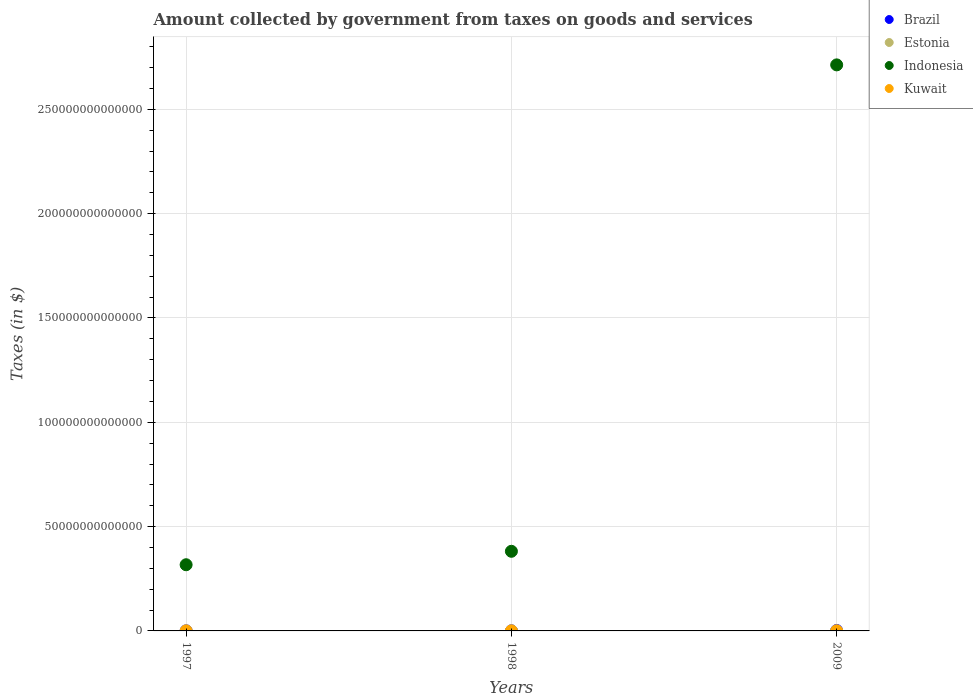Is the number of dotlines equal to the number of legend labels?
Provide a succinct answer. Yes. What is the amount collected by government from taxes on goods and services in Kuwait in 1998?
Make the answer very short. 1.00e+06. Across all years, what is the maximum amount collected by government from taxes on goods and services in Estonia?
Your response must be concise. 1.97e+09. In which year was the amount collected by government from taxes on goods and services in Estonia maximum?
Provide a short and direct response. 2009. In which year was the amount collected by government from taxes on goods and services in Brazil minimum?
Offer a very short reply. 1997. What is the total amount collected by government from taxes on goods and services in Kuwait in the graph?
Your response must be concise. 9.60e+07. What is the difference between the amount collected by government from taxes on goods and services in Kuwait in 1997 and that in 1998?
Offer a terse response. 0. What is the difference between the amount collected by government from taxes on goods and services in Kuwait in 1997 and the amount collected by government from taxes on goods and services in Indonesia in 2009?
Make the answer very short. -2.71e+14. What is the average amount collected by government from taxes on goods and services in Estonia per year?
Your answer should be very brief. 1.06e+09. In the year 1997, what is the difference between the amount collected by government from taxes on goods and services in Estonia and amount collected by government from taxes on goods and services in Indonesia?
Provide a short and direct response. -3.17e+13. In how many years, is the amount collected by government from taxes on goods and services in Estonia greater than 90000000000000 $?
Your answer should be compact. 0. What is the ratio of the amount collected by government from taxes on goods and services in Brazil in 1997 to that in 1998?
Make the answer very short. 0.91. Is the difference between the amount collected by government from taxes on goods and services in Estonia in 1997 and 2009 greater than the difference between the amount collected by government from taxes on goods and services in Indonesia in 1997 and 2009?
Provide a succinct answer. Yes. What is the difference between the highest and the second highest amount collected by government from taxes on goods and services in Estonia?
Give a very brief answer. 1.36e+09. What is the difference between the highest and the lowest amount collected by government from taxes on goods and services in Estonia?
Keep it short and to the point. 1.38e+09. Is the sum of the amount collected by government from taxes on goods and services in Estonia in 1998 and 2009 greater than the maximum amount collected by government from taxes on goods and services in Brazil across all years?
Your answer should be compact. No. Is it the case that in every year, the sum of the amount collected by government from taxes on goods and services in Indonesia and amount collected by government from taxes on goods and services in Kuwait  is greater than the sum of amount collected by government from taxes on goods and services in Estonia and amount collected by government from taxes on goods and services in Brazil?
Your response must be concise. No. Does the amount collected by government from taxes on goods and services in Indonesia monotonically increase over the years?
Give a very brief answer. Yes. Is the amount collected by government from taxes on goods and services in Brazil strictly greater than the amount collected by government from taxes on goods and services in Estonia over the years?
Make the answer very short. Yes. Is the amount collected by government from taxes on goods and services in Indonesia strictly less than the amount collected by government from taxes on goods and services in Estonia over the years?
Your response must be concise. No. How many years are there in the graph?
Provide a short and direct response. 3. What is the difference between two consecutive major ticks on the Y-axis?
Your response must be concise. 5.00e+13. Does the graph contain any zero values?
Provide a short and direct response. No. Does the graph contain grids?
Keep it short and to the point. Yes. How are the legend labels stacked?
Make the answer very short. Vertical. What is the title of the graph?
Your answer should be very brief. Amount collected by government from taxes on goods and services. Does "Serbia" appear as one of the legend labels in the graph?
Ensure brevity in your answer.  No. What is the label or title of the Y-axis?
Keep it short and to the point. Taxes (in $). What is the Taxes (in $) of Brazil in 1997?
Your response must be concise. 4.69e+1. What is the Taxes (in $) of Estonia in 1997?
Provide a succinct answer. 5.93e+08. What is the Taxes (in $) of Indonesia in 1997?
Ensure brevity in your answer.  3.17e+13. What is the Taxes (in $) of Brazil in 1998?
Keep it short and to the point. 5.17e+1. What is the Taxes (in $) in Estonia in 1998?
Make the answer very short. 6.05e+08. What is the Taxes (in $) in Indonesia in 1998?
Make the answer very short. 3.82e+13. What is the Taxes (in $) in Brazil in 2009?
Make the answer very short. 2.06e+11. What is the Taxes (in $) in Estonia in 2009?
Provide a succinct answer. 1.97e+09. What is the Taxes (in $) of Indonesia in 2009?
Offer a very short reply. 2.71e+14. What is the Taxes (in $) of Kuwait in 2009?
Offer a very short reply. 9.40e+07. Across all years, what is the maximum Taxes (in $) of Brazil?
Offer a very short reply. 2.06e+11. Across all years, what is the maximum Taxes (in $) in Estonia?
Make the answer very short. 1.97e+09. Across all years, what is the maximum Taxes (in $) of Indonesia?
Offer a very short reply. 2.71e+14. Across all years, what is the maximum Taxes (in $) in Kuwait?
Keep it short and to the point. 9.40e+07. Across all years, what is the minimum Taxes (in $) of Brazil?
Keep it short and to the point. 4.69e+1. Across all years, what is the minimum Taxes (in $) of Estonia?
Offer a very short reply. 5.93e+08. Across all years, what is the minimum Taxes (in $) of Indonesia?
Make the answer very short. 3.17e+13. What is the total Taxes (in $) of Brazil in the graph?
Provide a succinct answer. 3.04e+11. What is the total Taxes (in $) in Estonia in the graph?
Your response must be concise. 3.17e+09. What is the total Taxes (in $) in Indonesia in the graph?
Ensure brevity in your answer.  3.41e+14. What is the total Taxes (in $) in Kuwait in the graph?
Your answer should be very brief. 9.60e+07. What is the difference between the Taxes (in $) of Brazil in 1997 and that in 1998?
Make the answer very short. -4.82e+09. What is the difference between the Taxes (in $) of Estonia in 1997 and that in 1998?
Offer a terse response. -1.16e+07. What is the difference between the Taxes (in $) of Indonesia in 1997 and that in 1998?
Your response must be concise. -6.44e+12. What is the difference between the Taxes (in $) of Brazil in 1997 and that in 2009?
Offer a terse response. -1.59e+11. What is the difference between the Taxes (in $) of Estonia in 1997 and that in 2009?
Ensure brevity in your answer.  -1.38e+09. What is the difference between the Taxes (in $) of Indonesia in 1997 and that in 2009?
Provide a succinct answer. -2.40e+14. What is the difference between the Taxes (in $) of Kuwait in 1997 and that in 2009?
Your answer should be very brief. -9.30e+07. What is the difference between the Taxes (in $) of Brazil in 1998 and that in 2009?
Ensure brevity in your answer.  -1.54e+11. What is the difference between the Taxes (in $) in Estonia in 1998 and that in 2009?
Offer a very short reply. -1.36e+09. What is the difference between the Taxes (in $) in Indonesia in 1998 and that in 2009?
Provide a succinct answer. -2.33e+14. What is the difference between the Taxes (in $) in Kuwait in 1998 and that in 2009?
Keep it short and to the point. -9.30e+07. What is the difference between the Taxes (in $) of Brazil in 1997 and the Taxes (in $) of Estonia in 1998?
Offer a terse response. 4.63e+1. What is the difference between the Taxes (in $) of Brazil in 1997 and the Taxes (in $) of Indonesia in 1998?
Your answer should be compact. -3.81e+13. What is the difference between the Taxes (in $) of Brazil in 1997 and the Taxes (in $) of Kuwait in 1998?
Your response must be concise. 4.69e+1. What is the difference between the Taxes (in $) of Estonia in 1997 and the Taxes (in $) of Indonesia in 1998?
Give a very brief answer. -3.82e+13. What is the difference between the Taxes (in $) in Estonia in 1997 and the Taxes (in $) in Kuwait in 1998?
Provide a short and direct response. 5.92e+08. What is the difference between the Taxes (in $) of Indonesia in 1997 and the Taxes (in $) of Kuwait in 1998?
Your answer should be compact. 3.17e+13. What is the difference between the Taxes (in $) in Brazil in 1997 and the Taxes (in $) in Estonia in 2009?
Make the answer very short. 4.49e+1. What is the difference between the Taxes (in $) of Brazil in 1997 and the Taxes (in $) of Indonesia in 2009?
Offer a very short reply. -2.71e+14. What is the difference between the Taxes (in $) of Brazil in 1997 and the Taxes (in $) of Kuwait in 2009?
Offer a terse response. 4.68e+1. What is the difference between the Taxes (in $) in Estonia in 1997 and the Taxes (in $) in Indonesia in 2009?
Keep it short and to the point. -2.71e+14. What is the difference between the Taxes (in $) in Estonia in 1997 and the Taxes (in $) in Kuwait in 2009?
Your response must be concise. 4.99e+08. What is the difference between the Taxes (in $) in Indonesia in 1997 and the Taxes (in $) in Kuwait in 2009?
Offer a very short reply. 3.17e+13. What is the difference between the Taxes (in $) in Brazil in 1998 and the Taxes (in $) in Estonia in 2009?
Ensure brevity in your answer.  4.97e+1. What is the difference between the Taxes (in $) in Brazil in 1998 and the Taxes (in $) in Indonesia in 2009?
Offer a very short reply. -2.71e+14. What is the difference between the Taxes (in $) of Brazil in 1998 and the Taxes (in $) of Kuwait in 2009?
Offer a terse response. 5.16e+1. What is the difference between the Taxes (in $) in Estonia in 1998 and the Taxes (in $) in Indonesia in 2009?
Your answer should be compact. -2.71e+14. What is the difference between the Taxes (in $) in Estonia in 1998 and the Taxes (in $) in Kuwait in 2009?
Provide a short and direct response. 5.11e+08. What is the difference between the Taxes (in $) of Indonesia in 1998 and the Taxes (in $) of Kuwait in 2009?
Give a very brief answer. 3.82e+13. What is the average Taxes (in $) of Brazil per year?
Provide a short and direct response. 1.01e+11. What is the average Taxes (in $) in Estonia per year?
Provide a succinct answer. 1.06e+09. What is the average Taxes (in $) in Indonesia per year?
Provide a short and direct response. 1.14e+14. What is the average Taxes (in $) of Kuwait per year?
Give a very brief answer. 3.20e+07. In the year 1997, what is the difference between the Taxes (in $) in Brazil and Taxes (in $) in Estonia?
Provide a short and direct response. 4.63e+1. In the year 1997, what is the difference between the Taxes (in $) in Brazil and Taxes (in $) in Indonesia?
Provide a short and direct response. -3.17e+13. In the year 1997, what is the difference between the Taxes (in $) in Brazil and Taxes (in $) in Kuwait?
Give a very brief answer. 4.69e+1. In the year 1997, what is the difference between the Taxes (in $) of Estonia and Taxes (in $) of Indonesia?
Provide a short and direct response. -3.17e+13. In the year 1997, what is the difference between the Taxes (in $) in Estonia and Taxes (in $) in Kuwait?
Your response must be concise. 5.92e+08. In the year 1997, what is the difference between the Taxes (in $) in Indonesia and Taxes (in $) in Kuwait?
Your response must be concise. 3.17e+13. In the year 1998, what is the difference between the Taxes (in $) of Brazil and Taxes (in $) of Estonia?
Your response must be concise. 5.11e+1. In the year 1998, what is the difference between the Taxes (in $) of Brazil and Taxes (in $) of Indonesia?
Your answer should be very brief. -3.81e+13. In the year 1998, what is the difference between the Taxes (in $) of Brazil and Taxes (in $) of Kuwait?
Keep it short and to the point. 5.17e+1. In the year 1998, what is the difference between the Taxes (in $) of Estonia and Taxes (in $) of Indonesia?
Your answer should be compact. -3.82e+13. In the year 1998, what is the difference between the Taxes (in $) of Estonia and Taxes (in $) of Kuwait?
Offer a very short reply. 6.04e+08. In the year 1998, what is the difference between the Taxes (in $) of Indonesia and Taxes (in $) of Kuwait?
Provide a short and direct response. 3.82e+13. In the year 2009, what is the difference between the Taxes (in $) in Brazil and Taxes (in $) in Estonia?
Offer a terse response. 2.04e+11. In the year 2009, what is the difference between the Taxes (in $) in Brazil and Taxes (in $) in Indonesia?
Keep it short and to the point. -2.71e+14. In the year 2009, what is the difference between the Taxes (in $) in Brazil and Taxes (in $) in Kuwait?
Provide a succinct answer. 2.06e+11. In the year 2009, what is the difference between the Taxes (in $) of Estonia and Taxes (in $) of Indonesia?
Provide a succinct answer. -2.71e+14. In the year 2009, what is the difference between the Taxes (in $) in Estonia and Taxes (in $) in Kuwait?
Give a very brief answer. 1.88e+09. In the year 2009, what is the difference between the Taxes (in $) of Indonesia and Taxes (in $) of Kuwait?
Provide a short and direct response. 2.71e+14. What is the ratio of the Taxes (in $) in Brazil in 1997 to that in 1998?
Make the answer very short. 0.91. What is the ratio of the Taxes (in $) in Estonia in 1997 to that in 1998?
Your answer should be very brief. 0.98. What is the ratio of the Taxes (in $) of Indonesia in 1997 to that in 1998?
Offer a terse response. 0.83. What is the ratio of the Taxes (in $) in Brazil in 1997 to that in 2009?
Offer a very short reply. 0.23. What is the ratio of the Taxes (in $) of Estonia in 1997 to that in 2009?
Offer a terse response. 0.3. What is the ratio of the Taxes (in $) of Indonesia in 1997 to that in 2009?
Ensure brevity in your answer.  0.12. What is the ratio of the Taxes (in $) in Kuwait in 1997 to that in 2009?
Keep it short and to the point. 0.01. What is the ratio of the Taxes (in $) of Brazil in 1998 to that in 2009?
Offer a very short reply. 0.25. What is the ratio of the Taxes (in $) in Estonia in 1998 to that in 2009?
Your answer should be compact. 0.31. What is the ratio of the Taxes (in $) of Indonesia in 1998 to that in 2009?
Provide a short and direct response. 0.14. What is the ratio of the Taxes (in $) of Kuwait in 1998 to that in 2009?
Ensure brevity in your answer.  0.01. What is the difference between the highest and the second highest Taxes (in $) of Brazil?
Offer a terse response. 1.54e+11. What is the difference between the highest and the second highest Taxes (in $) of Estonia?
Provide a succinct answer. 1.36e+09. What is the difference between the highest and the second highest Taxes (in $) in Indonesia?
Your answer should be compact. 2.33e+14. What is the difference between the highest and the second highest Taxes (in $) in Kuwait?
Provide a short and direct response. 9.30e+07. What is the difference between the highest and the lowest Taxes (in $) in Brazil?
Ensure brevity in your answer.  1.59e+11. What is the difference between the highest and the lowest Taxes (in $) in Estonia?
Your response must be concise. 1.38e+09. What is the difference between the highest and the lowest Taxes (in $) in Indonesia?
Your answer should be compact. 2.40e+14. What is the difference between the highest and the lowest Taxes (in $) in Kuwait?
Offer a very short reply. 9.30e+07. 